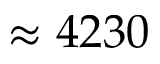Convert formula to latex. <formula><loc_0><loc_0><loc_500><loc_500>\approx 4 2 3 0</formula> 